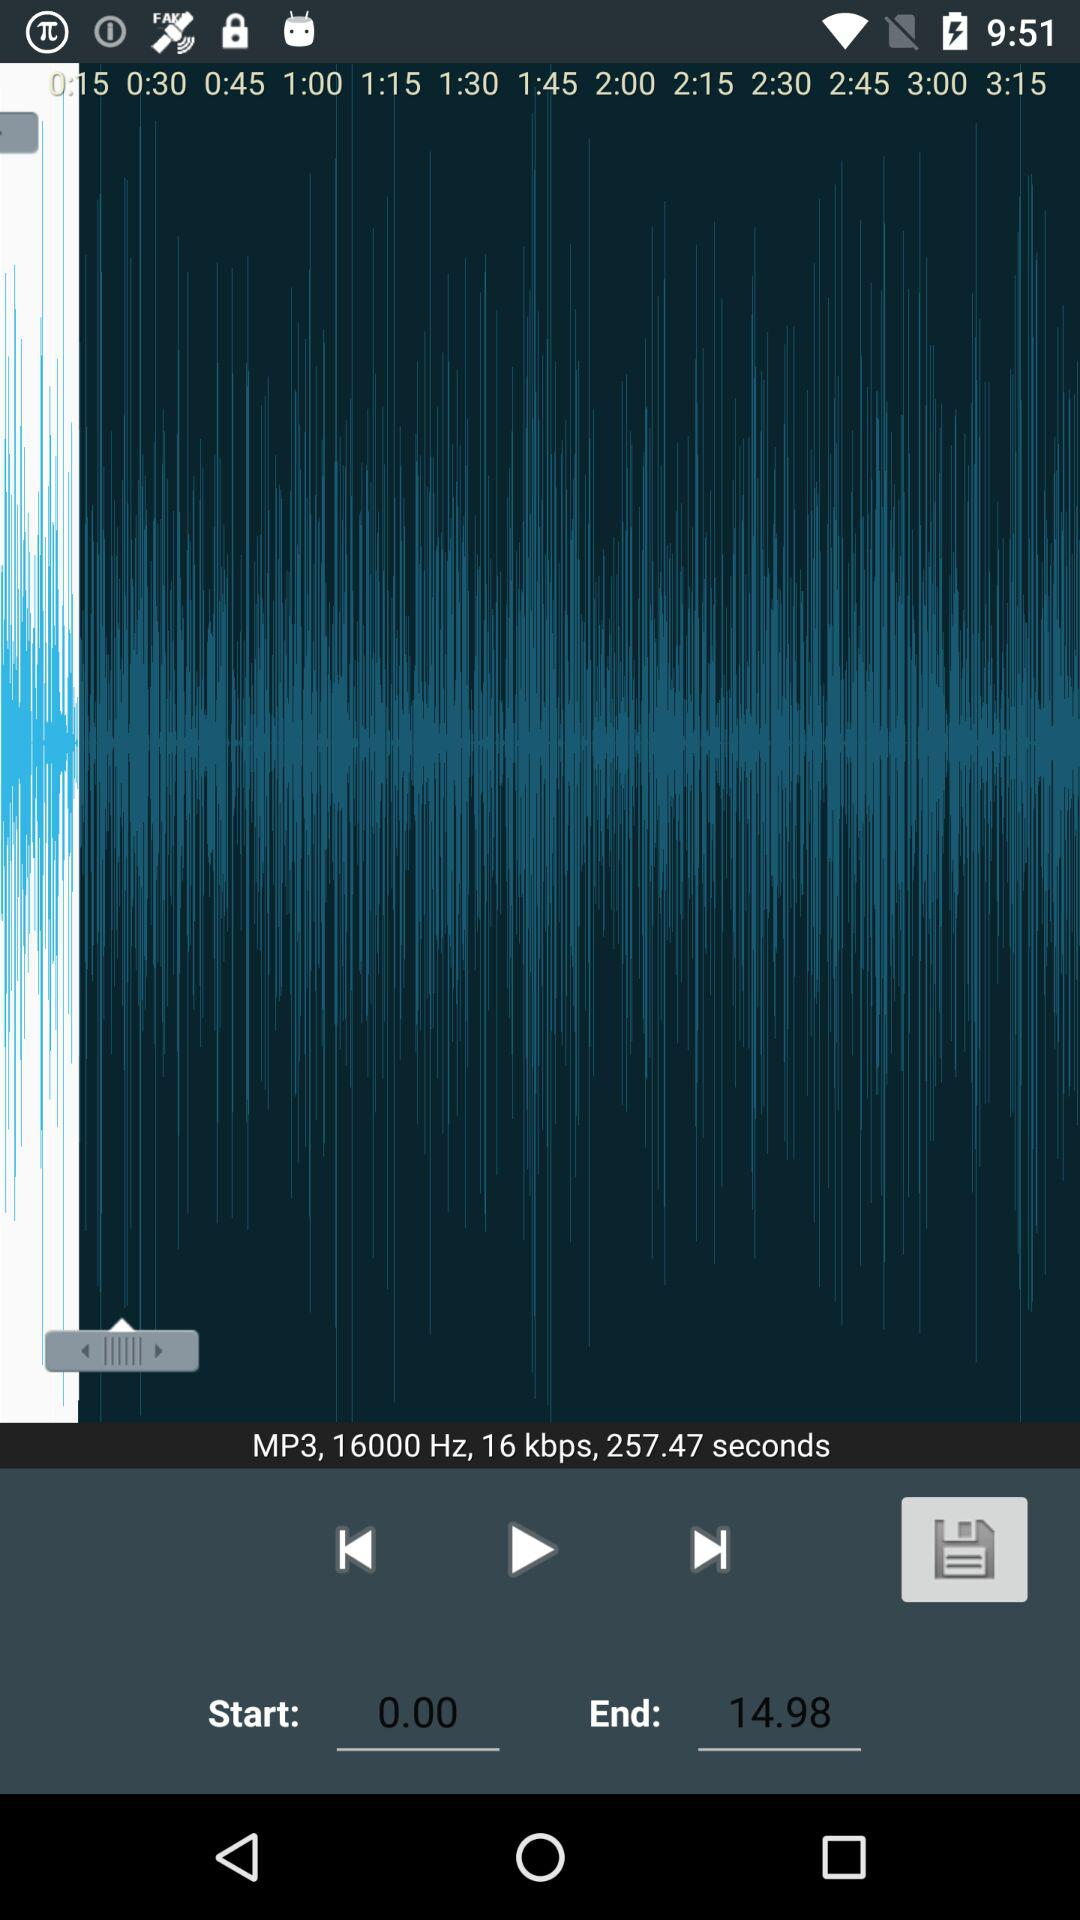How long is the audio file in seconds?
Answer the question using a single word or phrase. 257.47 